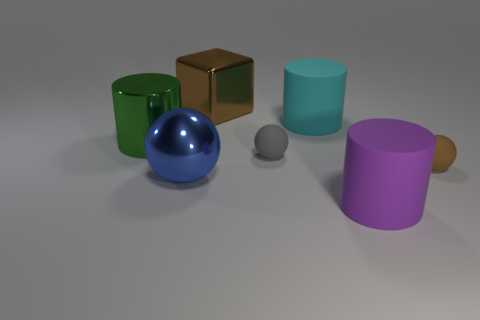Subtract all blue spheres. Subtract all purple cylinders. How many spheres are left? 2 Subtract all green cubes. How many green cylinders are left? 1 Add 3 large grays. How many large cyans exist? 0 Subtract all tiny gray spheres. Subtract all large metal things. How many objects are left? 3 Add 6 large cyan things. How many large cyan things are left? 7 Add 2 big red shiny cubes. How many big red shiny cubes exist? 2 Add 2 cyan spheres. How many objects exist? 9 Subtract all cyan cylinders. How many cylinders are left? 2 Subtract all brown balls. How many balls are left? 2 Subtract 1 cyan cylinders. How many objects are left? 6 